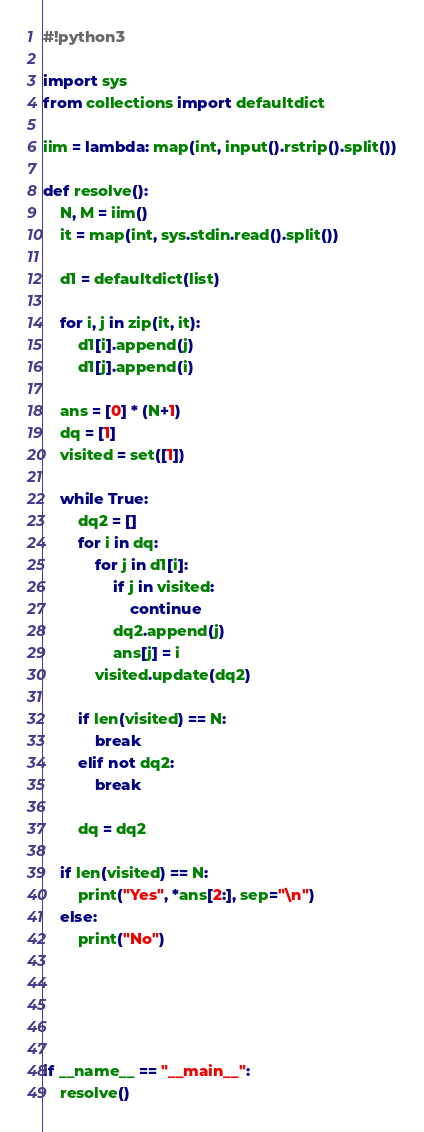<code> <loc_0><loc_0><loc_500><loc_500><_Python_>#!python3

import sys
from collections import defaultdict

iim = lambda: map(int, input().rstrip().split())

def resolve():
    N, M = iim()
    it = map(int, sys.stdin.read().split())

    d1 = defaultdict(list)

    for i, j in zip(it, it):
        d1[i].append(j)
        d1[j].append(i)

    ans = [0] * (N+1)
    dq = [1]
    visited = set([1])

    while True:
        dq2 = []
        for i in dq:
            for j in d1[i]:
                if j in visited:
                    continue
                dq2.append(j)
                ans[j] = i
            visited.update(dq2)

        if len(visited) == N:
            break
        elif not dq2:
            break

        dq = dq2

    if len(visited) == N:
        print("Yes", *ans[2:], sep="\n")
    else:
        print("No")





if __name__ == "__main__":
    resolve()
</code> 